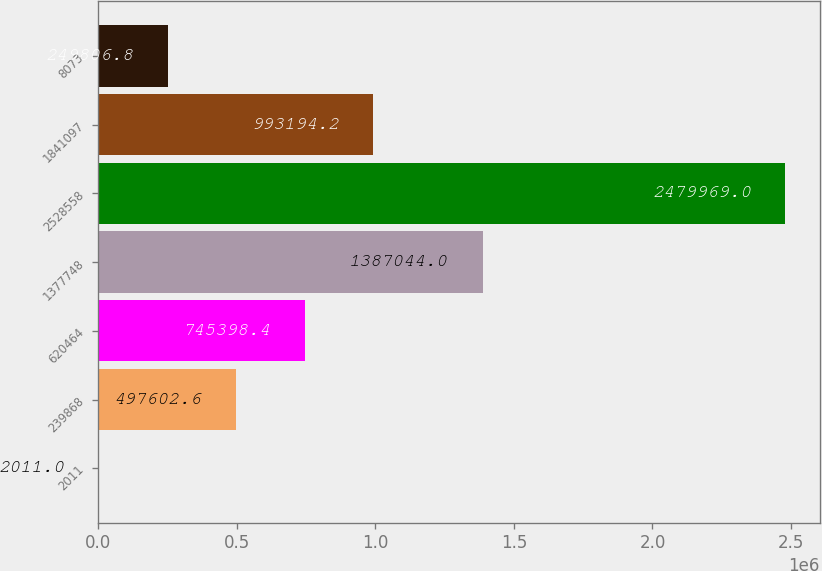<chart> <loc_0><loc_0><loc_500><loc_500><bar_chart><fcel>2011<fcel>239868<fcel>620464<fcel>1377748<fcel>2528558<fcel>1841097<fcel>8073<nl><fcel>2011<fcel>497603<fcel>745398<fcel>1.38704e+06<fcel>2.47997e+06<fcel>993194<fcel>249807<nl></chart> 